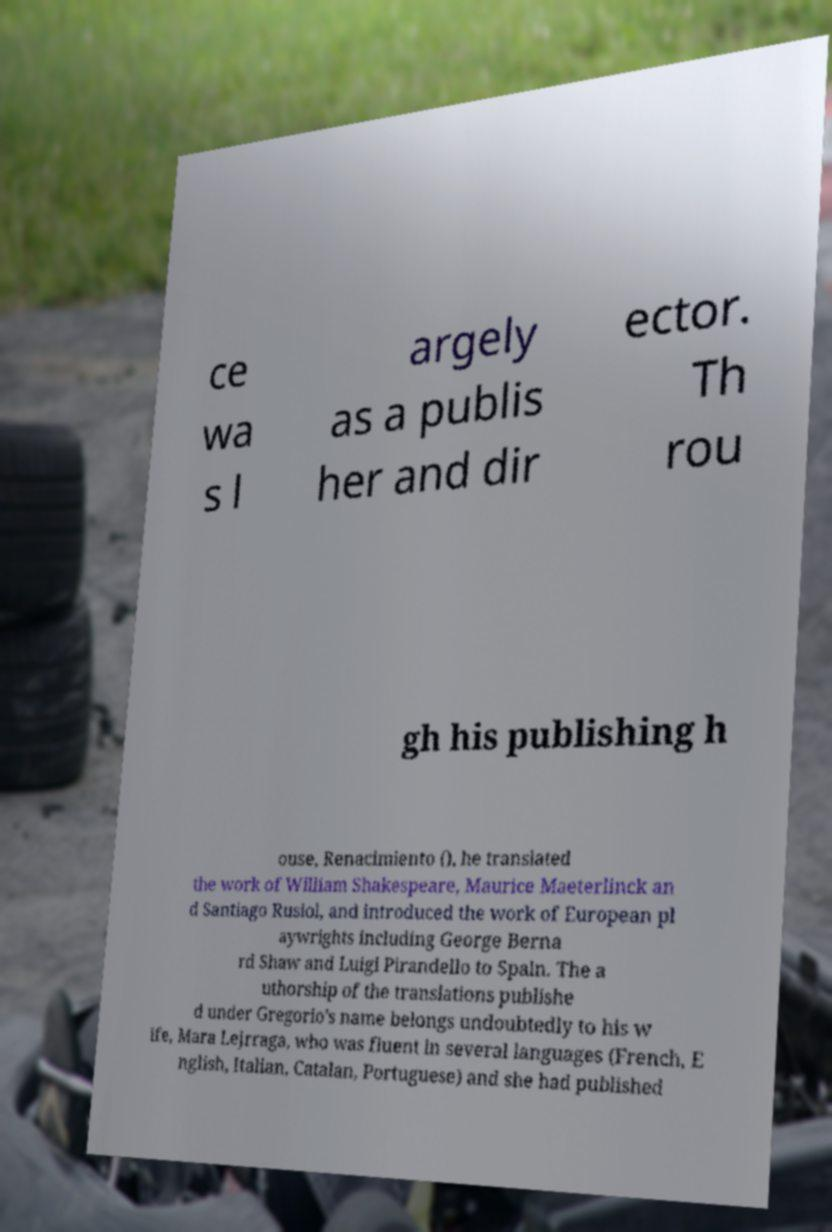Can you accurately transcribe the text from the provided image for me? ce wa s l argely as a publis her and dir ector. Th rou gh his publishing h ouse, Renacimiento (), he translated the work of William Shakespeare, Maurice Maeterlinck an d Santiago Rusiol, and introduced the work of European pl aywrights including George Berna rd Shaw and Luigi Pirandello to Spain. The a uthorship of the translations publishe d under Gregorio's name belongs undoubtedly to his w ife, Mara Lejrraga, who was fluent in several languages (French, E nglish, Italian, Catalan, Portuguese) and she had published 